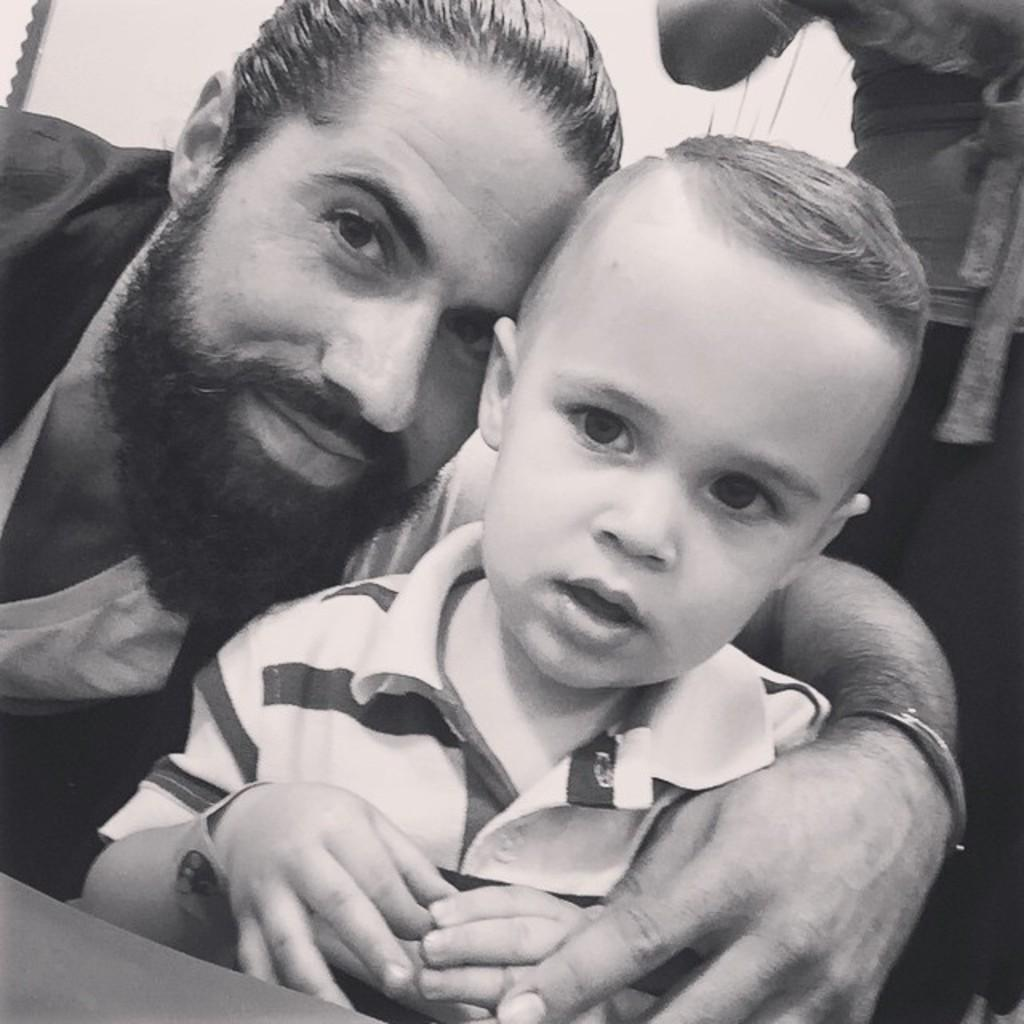What is the color scheme of the image? The image is black and white. Who can be seen in the image? There is a man and a kid in the image. Are there any other people visible in the image? Yes, there is a person in the background of the image. What type of art is the kid creating in the image? There is no indication of the kid creating any art in the image, as it is a black and white image featuring a man, a kid, and a person in the background. What game is the man playing with the kid in the image? There is no game being played in the image; it simply shows a man and a kid in a black and white setting. 